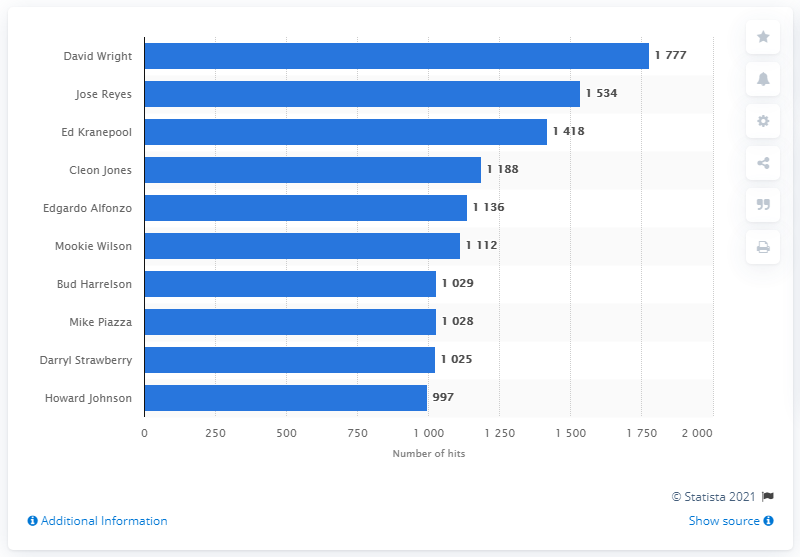Draw attention to some important aspects in this diagram. The person with the most hits in the history of the New York Mets franchise is David Wright. 